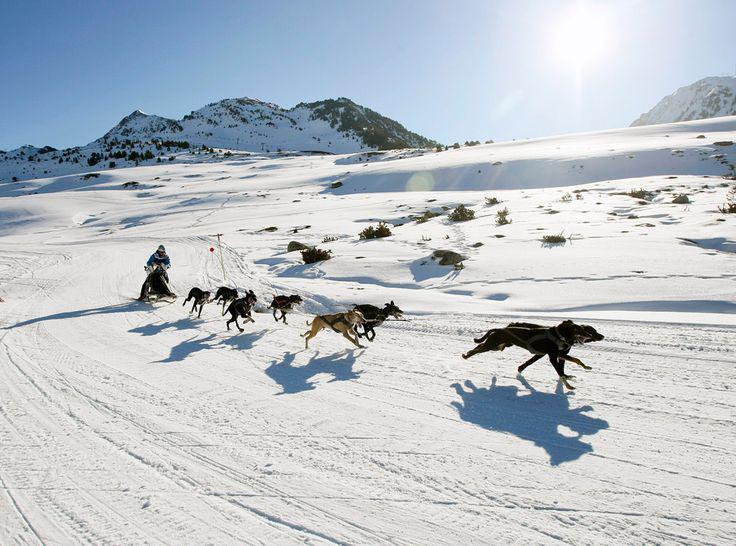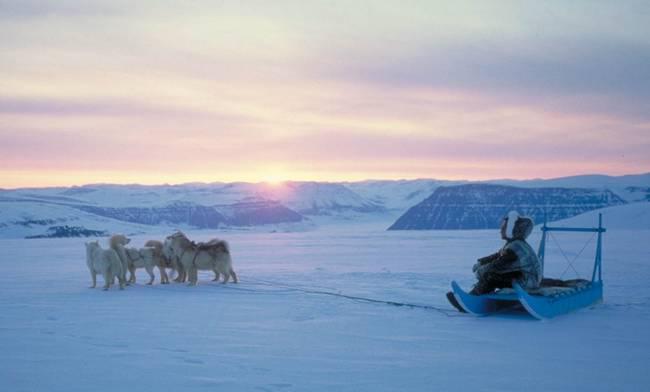The first image is the image on the left, the second image is the image on the right. For the images displayed, is the sentence "There is more than one human visible in at least one of the images." factually correct? Answer yes or no. No. 